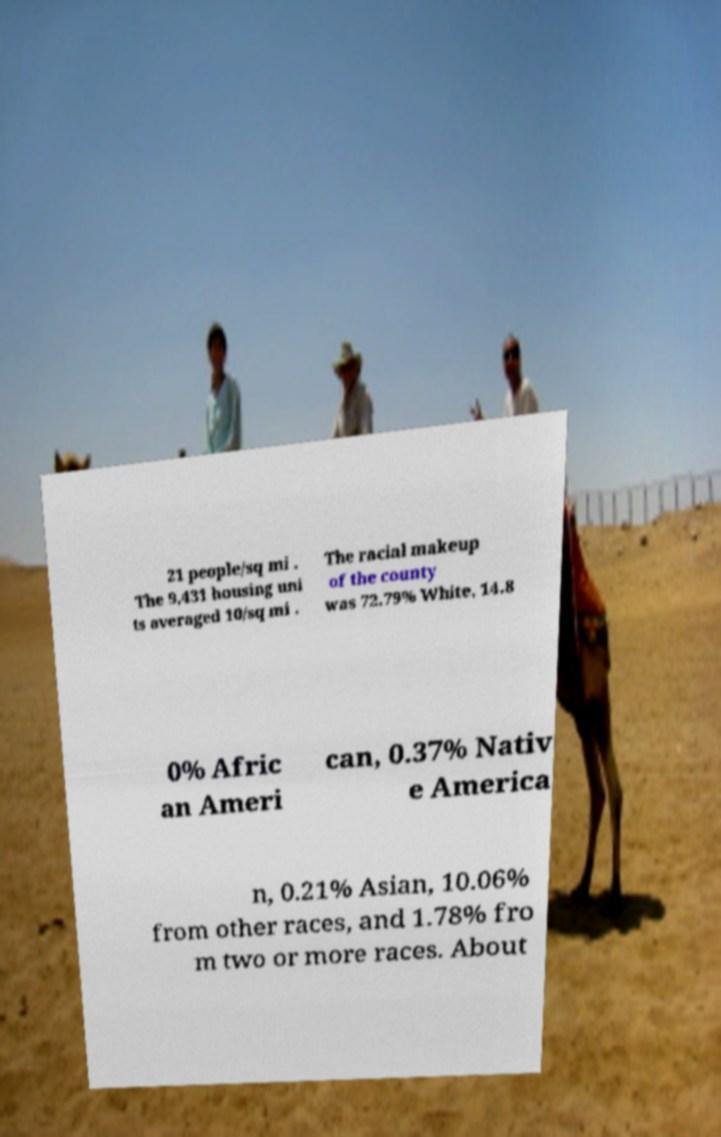Please identify and transcribe the text found in this image. 21 people/sq mi . The 9,431 housing uni ts averaged 10/sq mi . The racial makeup of the county was 72.79% White, 14.8 0% Afric an Ameri can, 0.37% Nativ e America n, 0.21% Asian, 10.06% from other races, and 1.78% fro m two or more races. About 